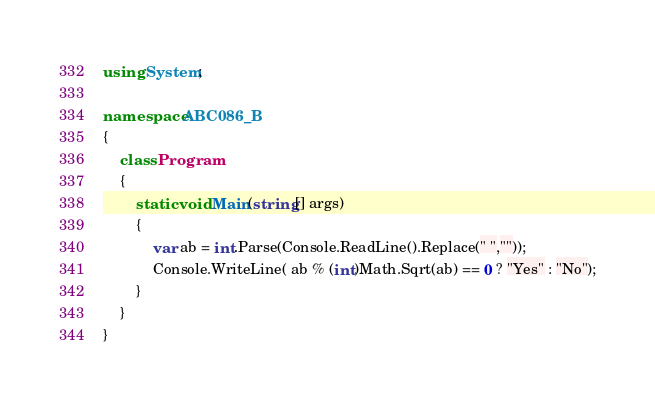<code> <loc_0><loc_0><loc_500><loc_500><_C#_>using System;

namespace ABC086_B
{
    class Program
    {
        static void Main(string[] args)
        {
            var ab = int.Parse(Console.ReadLine().Replace(" ",""));
            Console.WriteLine( ab % (int)Math.Sqrt(ab) == 0 ? "Yes" : "No");
        }
    }
}
</code> 